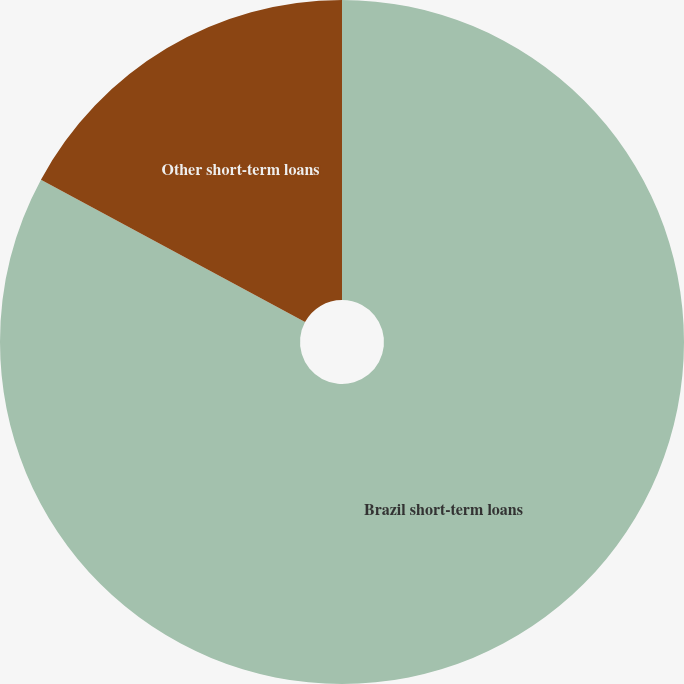Convert chart to OTSL. <chart><loc_0><loc_0><loc_500><loc_500><pie_chart><fcel>Brazil short-term loans<fcel>Other short-term loans<nl><fcel>82.87%<fcel>17.13%<nl></chart> 